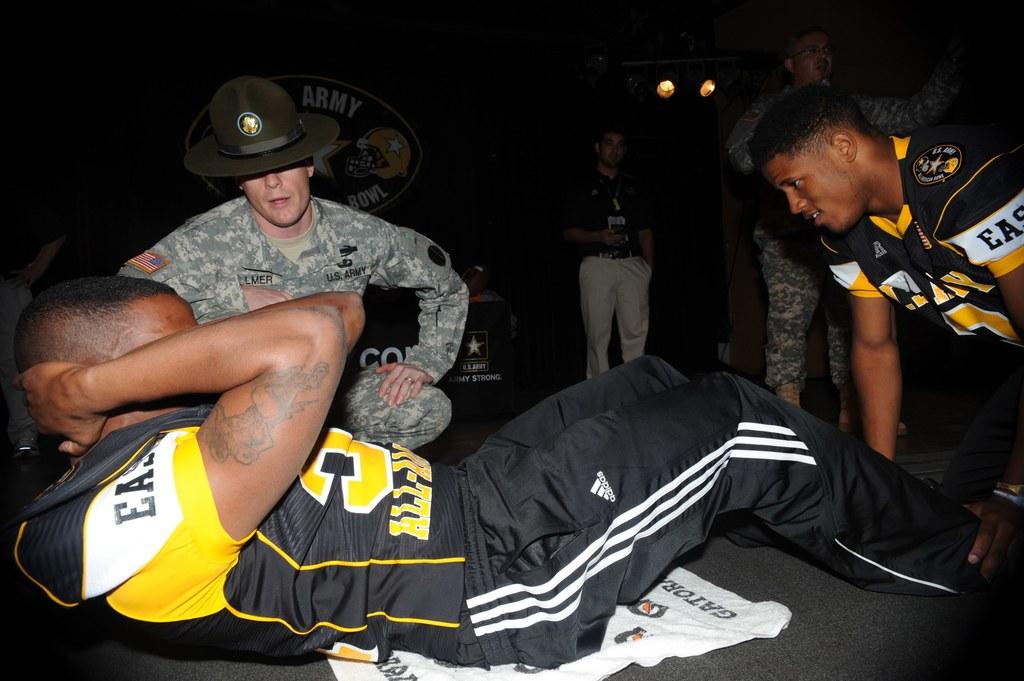What brand of clothing does the black and white striped pants belong to?
Make the answer very short. Adidas. 